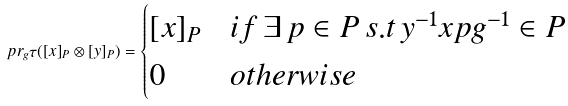Convert formula to latex. <formula><loc_0><loc_0><loc_500><loc_500>p r _ { g } \tau ( [ x ] _ { P } \otimes [ y ] _ { P } ) = \begin{cases} [ x ] _ { P } & i f \, \exists \, p \in P \, s . t \, y ^ { - 1 } x p g ^ { - 1 } \in P \\ 0 & o t h e r w i s e \end{cases}</formula> 